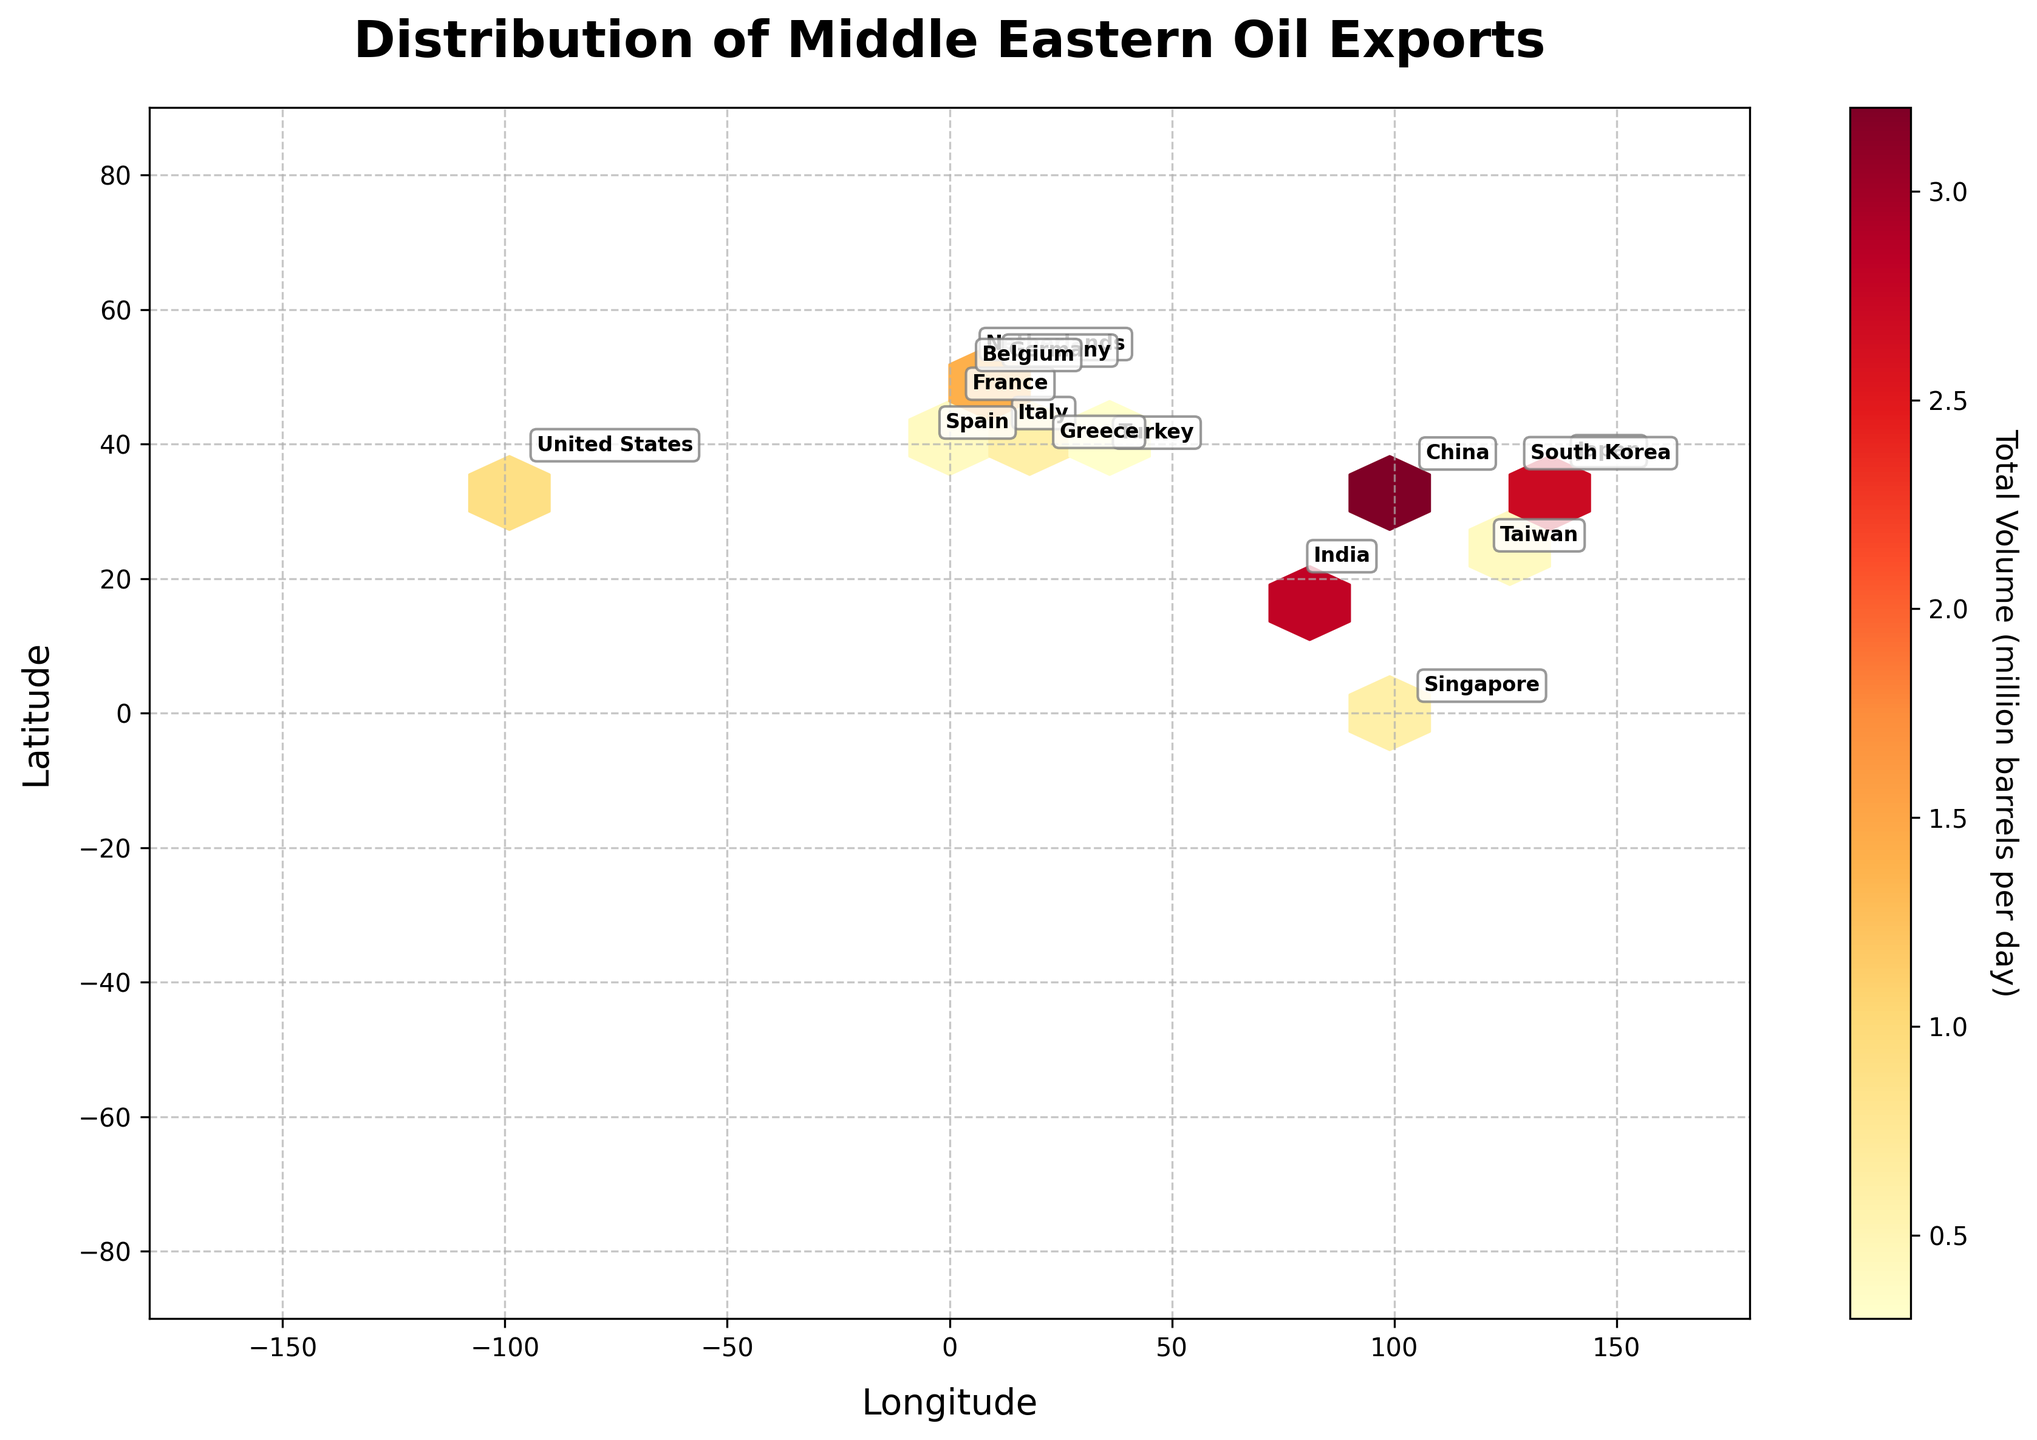What is the title of the plot? The title of the plot is displayed at the top and reads "Distribution of Middle Eastern Oil Exports".
Answer: Distribution of Middle Eastern Oil Exports What is the color of the hexagons with the highest total volume? By observing the color gradient of the hexagons, the hexagons with the highest total volume are the darkest shade of red.
Answer: Dark red Which country has the highest volume of oil exports from the Middle East? The country labeled closest to the darkest hexagon indicates the highest volume of oil exports. According to the annotations, China is associated with the darkest shade of red.
Answer: China What is indicated on the x-axis of the plot? The x-axis of the plot is labeled "Longitude".
Answer: Longitude What is the total volume of oil exported to the top three destinations combined? By identifying the top three destinations by their respective volumes: China (3.2), India (2.8), and Japan (1.5), the total volume is calculated as 3.2 + 2.8 + 1.5.
Answer: 7.5 million barrels per day Which country receives less oil exports from the Middle East: France or Germany? The annotations show the volume for France as 0.3 and for Germany as 0.2. Therefore, Germany receives less oil exports.
Answer: Germany At approximately which coordinates is the largest hexagon located? The largest hexagon, corresponding to the highest volume, is located around the longitude of 104.1954 and latitude of 35.8617, near China's coordinates.
Answer: (104.1954, 35.8617) How does the volume exported to the United States compare to that exported to South Korea? The volumes for the United States and South Korea are labeled as 0.9 and 1.2 respectively. Thus, the United States receives less oil than South Korea.
Answer: The United States receives less How many data points (countries) are visualized in the plot? By counting the number of unique countries labeled on the plot, there are 15 data points.
Answer: 15 